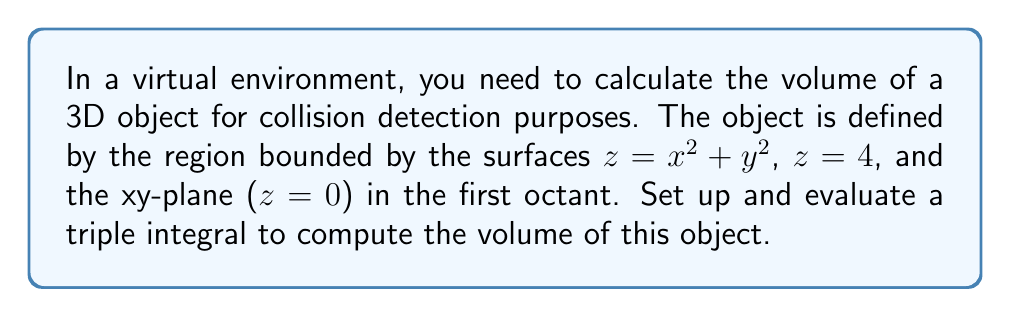Solve this math problem. To solve this problem, we'll follow these steps:

1) Visualize the object:
   The object is bounded by a paraboloid $z = x^2 + y^2$, a horizontal plane $z = 4$, and the xy-plane $z = 0$, all in the first octant (where x, y, and z are non-negative).

2) Determine the integration limits:
   - For z: From $z = 0$ to $z = \min(x^2 + y^2, 4)$
   - For x and y: The projection of the object onto the xy-plane is a quarter circle with radius 2 (where the paraboloid intersects the plane $z = 4$)

3) Set up the triple integral:
   $$V = \iiint_V dV = \int_0^2 \int_0^{\sqrt{4-x^2}} \int_0^{\min(x^2+y^2, 4)} dz dy dx$$

4) Evaluate the inner integral (with respect to z):
   $$V = \int_0^2 \int_0^{\sqrt{4-x^2}} \min(x^2+y^2, 4) dy dx$$

5) Split the integral based on where $x^2 + y^2 = 4$:
   $$V = \int_0^{\sqrt{2}} \int_0^{\sqrt{4-x^2}} (x^2+y^2) dy dx + \int_{\sqrt{2}}^2 \int_0^{\sqrt{4-x^2}} 4 dy dx$$

6) Evaluate the first double integral:
   $$\int_0^{\sqrt{2}} \int_0^{\sqrt{4-x^2}} (x^2+y^2) dy dx$$
   $$= \int_0^{\sqrt{2}} [x^2y + \frac{1}{3}y^3]_0^{\sqrt{4-x^2}} dx$$
   $$= \int_0^{\sqrt{2}} (x^2\sqrt{4-x^2} + \frac{1}{3}(4-x^2)^{3/2}) dx$$

7) Evaluate the second double integral:
   $$\int_{\sqrt{2}}^2 \int_0^{\sqrt{4-x^2}} 4 dy dx = \int_{\sqrt{2}}^2 4\sqrt{4-x^2} dx$$

8) The sum of these integrals gives the volume. These integrals can be evaluated using substitution and trigonometric substitutions, resulting in:

   $$V = \frac{16\pi - 16}{3}$$
Answer: The volume of the 3D object is $\frac{16\pi - 16}{3}$ cubic units. 